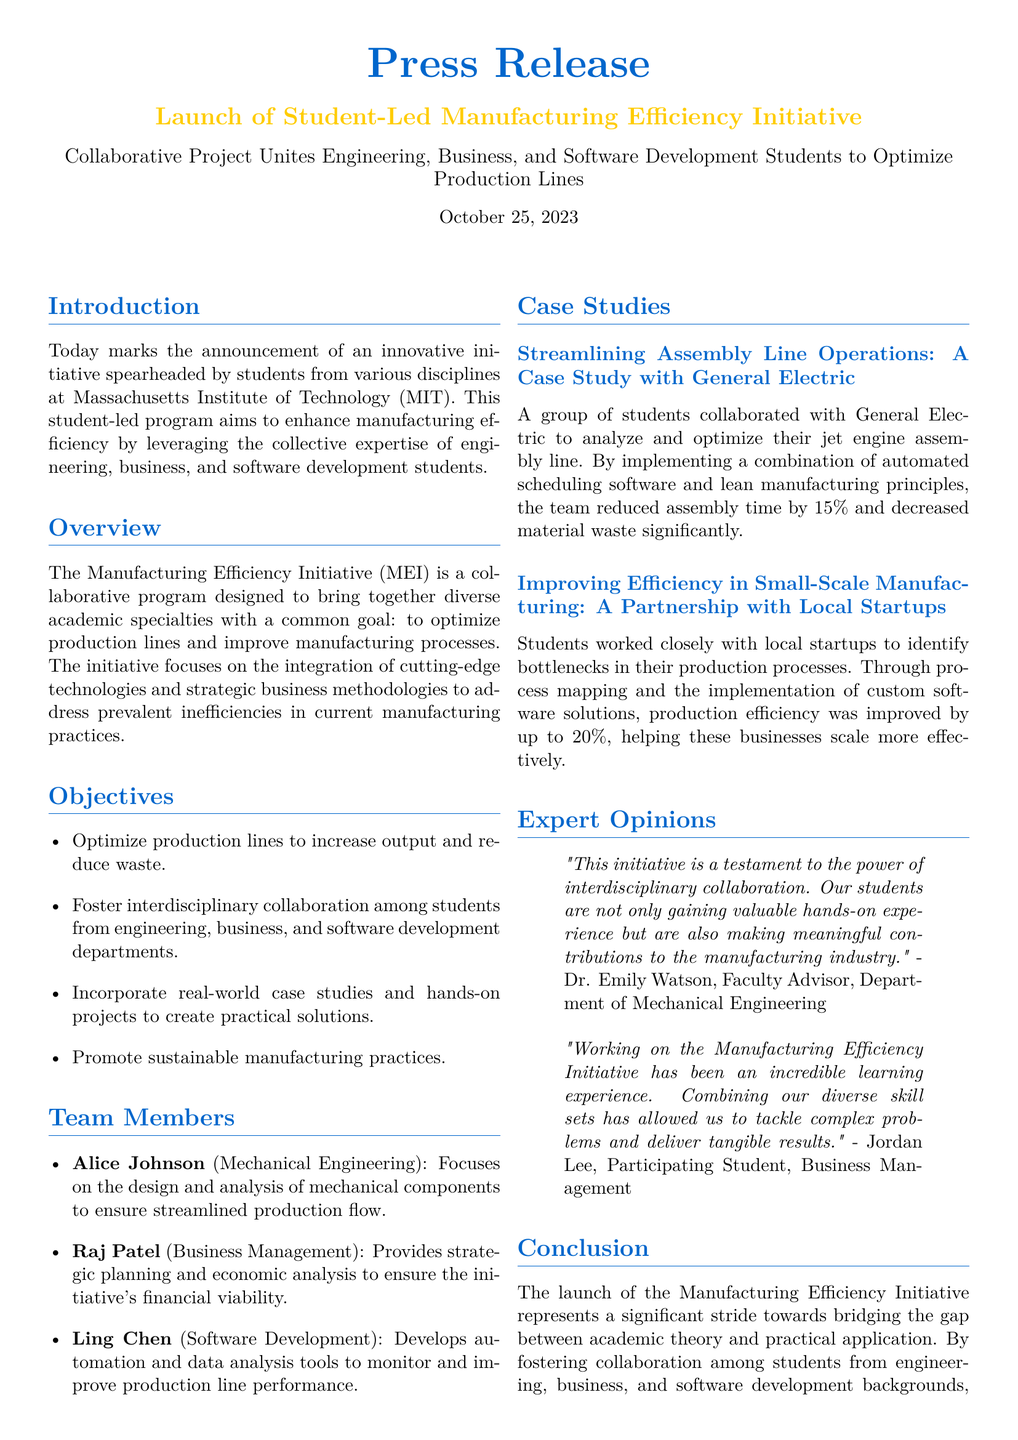What is the date of the press release? The date of the press release is stated at the end of the introductory section.
Answer: October 25, 2023 Who is a faculty advisor mentioned in the document? The faculty advisor's name is included in the Expert Opinions section.
Answer: Dr. Emily Watson What is the focus of Ling Chen's role in the initiative? Ling Chen's focus is detailed under the Team Members section.
Answer: Develops automation and data analysis tools How much efficiency was improved for small-scale manufacturing? This figure is presented in the case studies section regarding local startups.
Answer: 20 percent What is the main goal of the Manufacturing Efficiency Initiative? The goal is outlined in the Overview section of the press release.
Answer: Optimize production lines Who collaborated with students to analyze the jet engine assembly line? This collaboration is noted in the case studies section.
Answer: General Electric What principle was combined with automated scheduling software in the GE case study? This principle is mentioned in relation to the case study with General Electric.
Answer: Lean manufacturing 